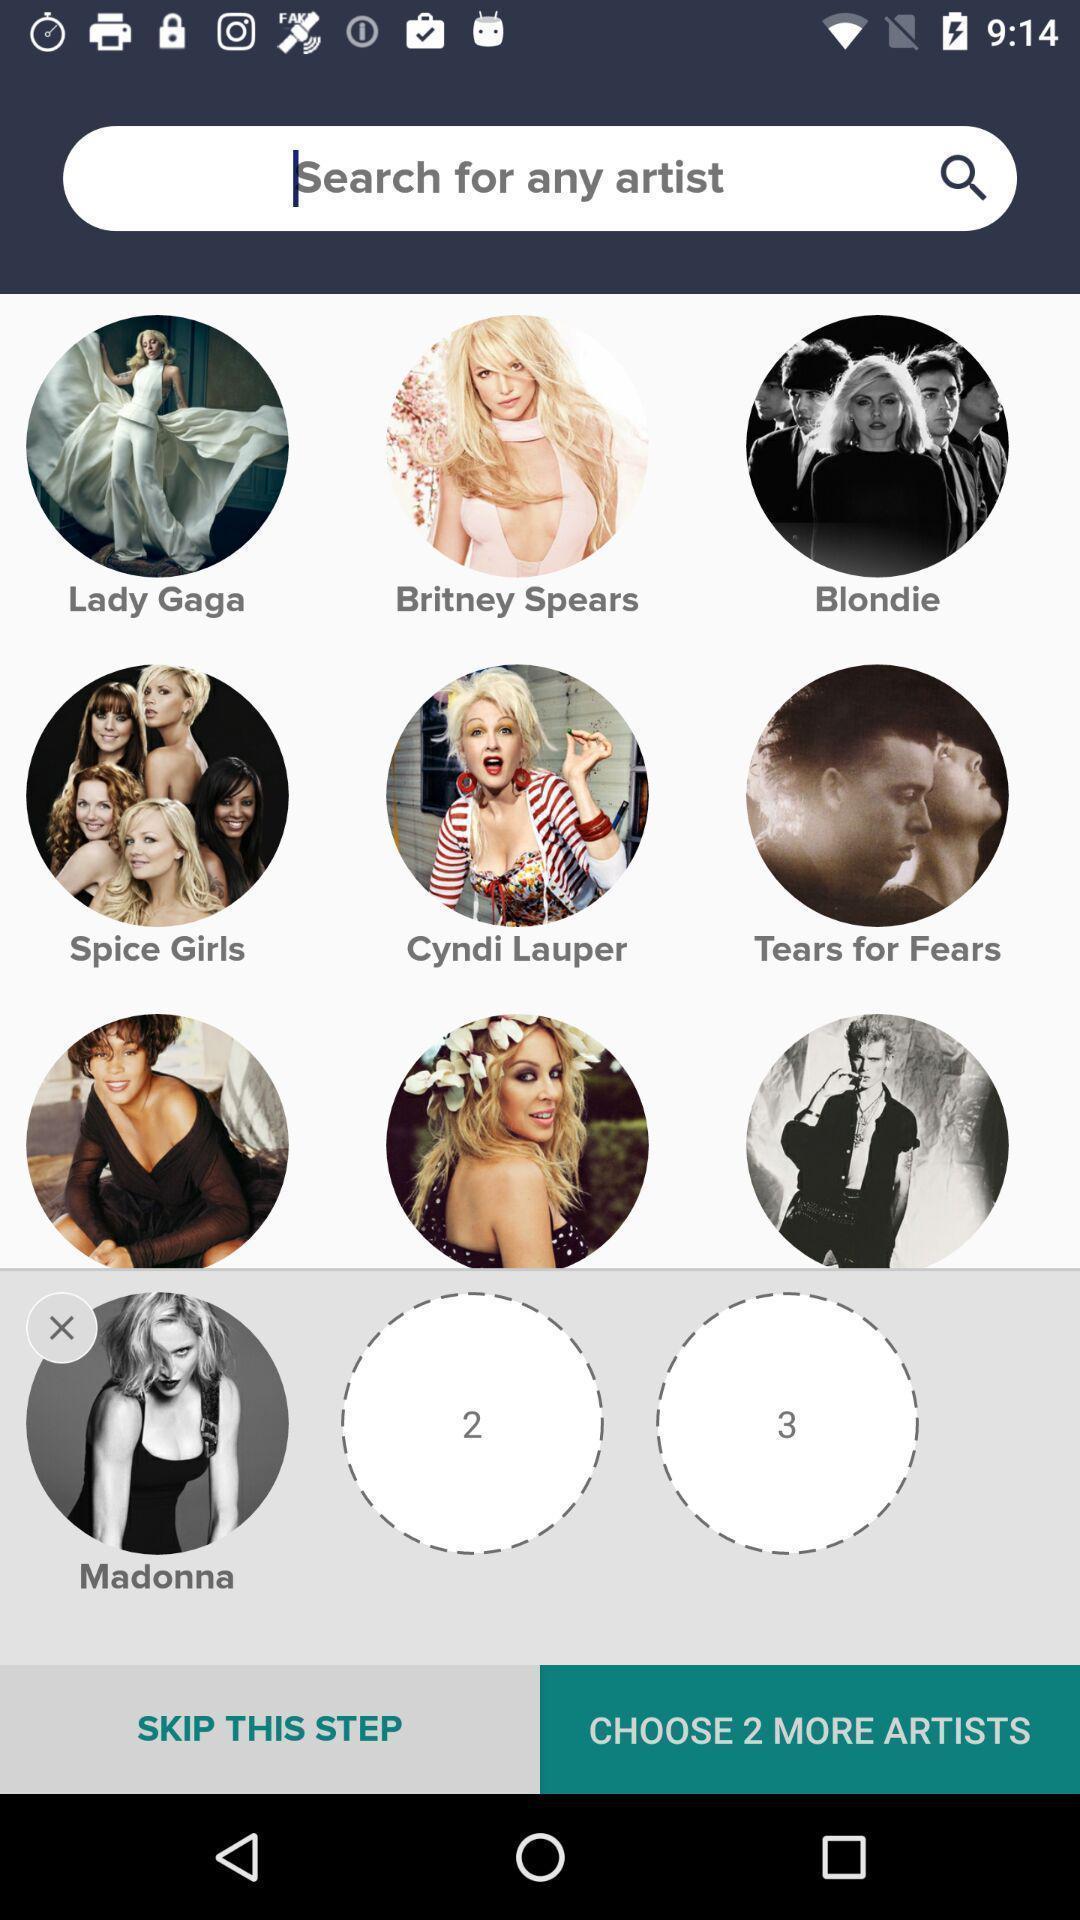Describe the content in this image. Search bar to search songs artist for music app. 